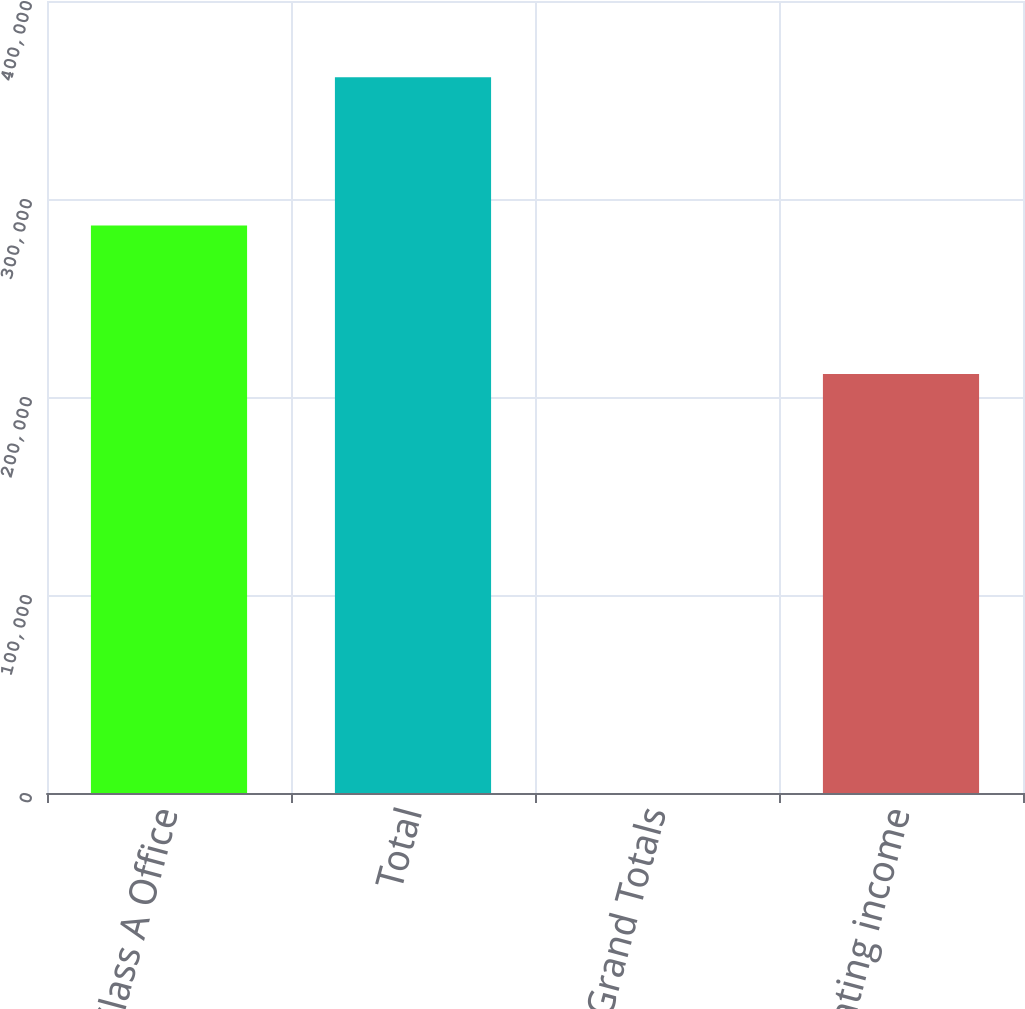<chart> <loc_0><loc_0><loc_500><loc_500><bar_chart><fcel>Class A Office<fcel>Total<fcel>of Grand Totals<fcel>Net operating income<nl><fcel>286568<fcel>361520<fcel>26.67<fcel>211601<nl></chart> 